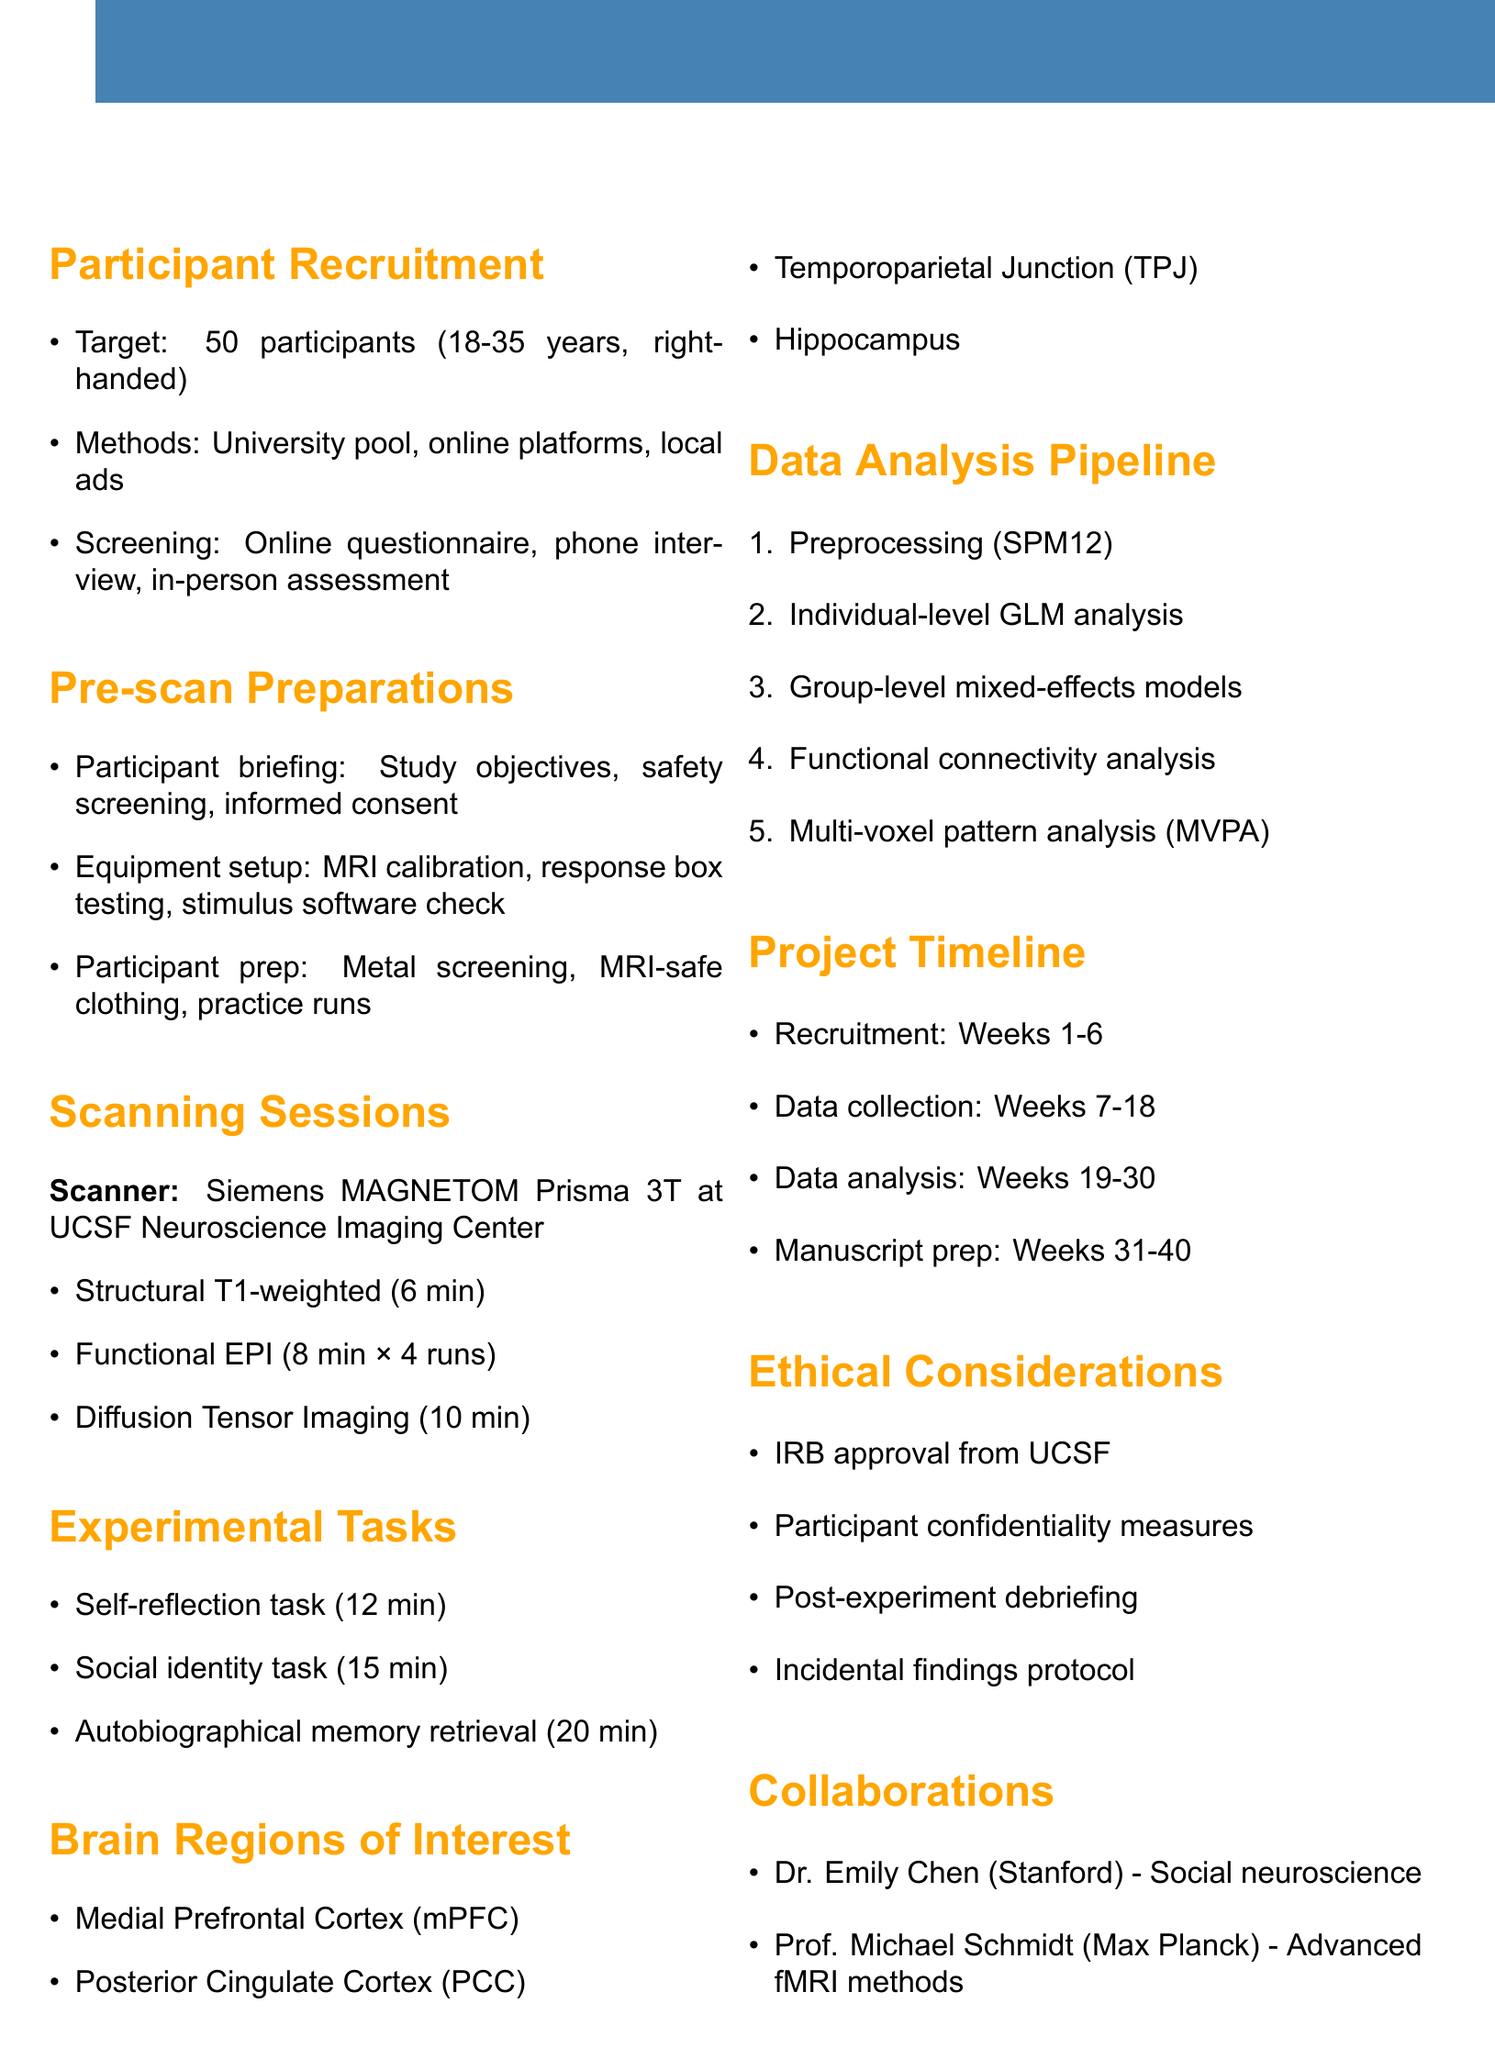What is the target sample size for participants? The document states that the target sample size is specified in the participant recruitment section.
Answer: 50 What age range are participants required to be in? The inclusion criteria for participants include specific age requirements outlined under participant recruitment.
Answer: 18-35 Which MRI scanner model will be used for the experiments? The details about the scanning sessions include specifications of the scanner used in the experiments.
Answer: Siemens MAGNETOM Prisma 3T How long is the self-reflection task? The experimental tasks section details the duration for each task, including the self-reflection task.
Answer: 12 minutes What is the duration for diffusion tensor imaging? The scanning session details include the specific duration for each imaging sequence, including diffusion tensor imaging.
Answer: 10 minutes Who is collaborating from Stanford University? The collaboration opportunities section provides the names and institutions of researchers involved, including one from Stanford.
Answer: Dr. Emily Chen What is the duration of the data collection phase? The project timeline outlines the timeframes for various stages, including data collection.
Answer: Weeks 7-18 What software will be used for preprocessing data? The data analysis pipeline mentions the specific software used for preprocessing in the analysis of the data collected.
Answer: SPM12 What are the ethical considerations mentioned in the document? The ethical considerations section lists the protocols and measures taken for ethical compliance in the study.
Answer: IRB approval, confidentiality, debriefing, incidental findings protocol 